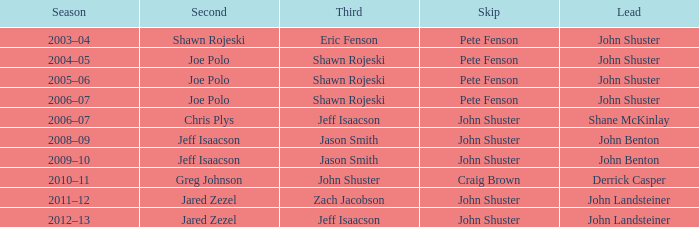Which season has Zach Jacobson in third? 2011–12. 